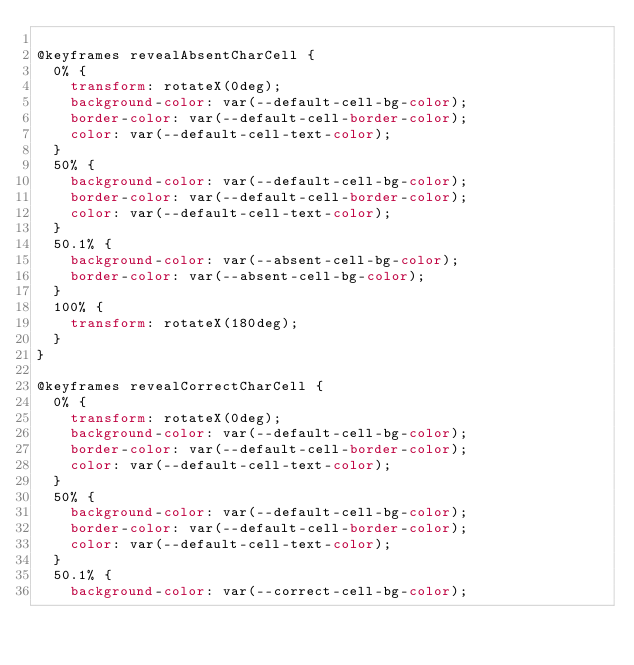<code> <loc_0><loc_0><loc_500><loc_500><_CSS_>
@keyframes revealAbsentCharCell {
  0% {
    transform: rotateX(0deg);
    background-color: var(--default-cell-bg-color);
    border-color: var(--default-cell-border-color);
    color: var(--default-cell-text-color);
  }
  50% {
    background-color: var(--default-cell-bg-color);
    border-color: var(--default-cell-border-color);
    color: var(--default-cell-text-color);
  }
  50.1% {
    background-color: var(--absent-cell-bg-color);
    border-color: var(--absent-cell-bg-color);
  }
  100% {
    transform: rotateX(180deg);
  }
}

@keyframes revealCorrectCharCell {
  0% {
    transform: rotateX(0deg);
    background-color: var(--default-cell-bg-color);
    border-color: var(--default-cell-border-color);
    color: var(--default-cell-text-color);
  }
  50% {
    background-color: var(--default-cell-bg-color);
    border-color: var(--default-cell-border-color);
    color: var(--default-cell-text-color);
  }
  50.1% {
    background-color: var(--correct-cell-bg-color);</code> 